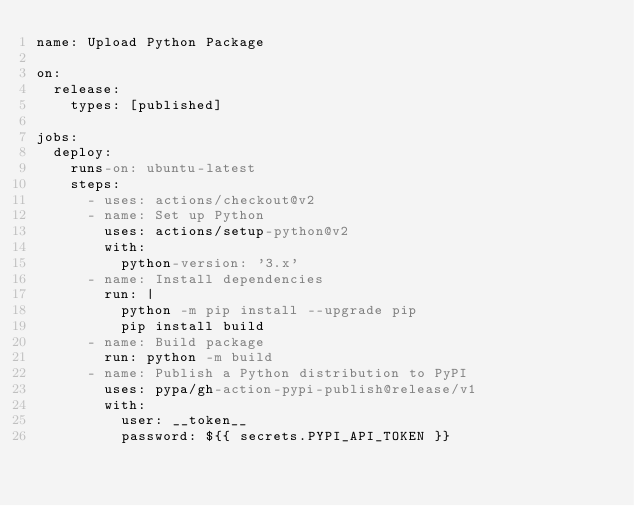<code> <loc_0><loc_0><loc_500><loc_500><_YAML_>name: Upload Python Package

on:
  release:
    types: [published]

jobs:
  deploy:
    runs-on: ubuntu-latest
    steps:
      - uses: actions/checkout@v2
      - name: Set up Python
        uses: actions/setup-python@v2
        with:
          python-version: '3.x'
      - name: Install dependencies
        run: |
          python -m pip install --upgrade pip
          pip install build
      - name: Build package
        run: python -m build
      - name: Publish a Python distribution to PyPI
        uses: pypa/gh-action-pypi-publish@release/v1
        with:
          user: __token__
          password: ${{ secrets.PYPI_API_TOKEN }}
</code> 